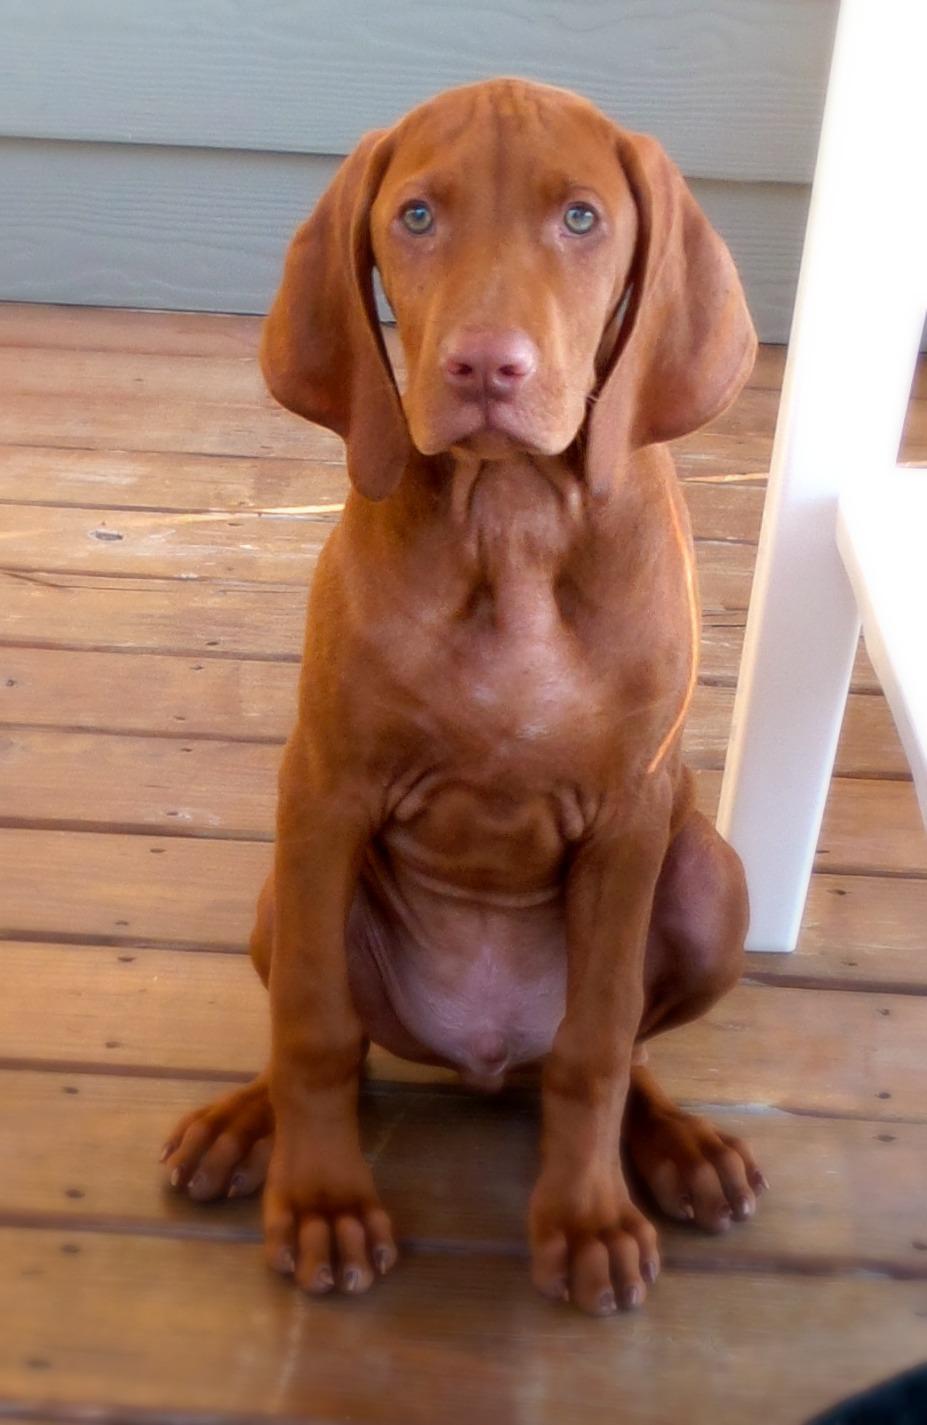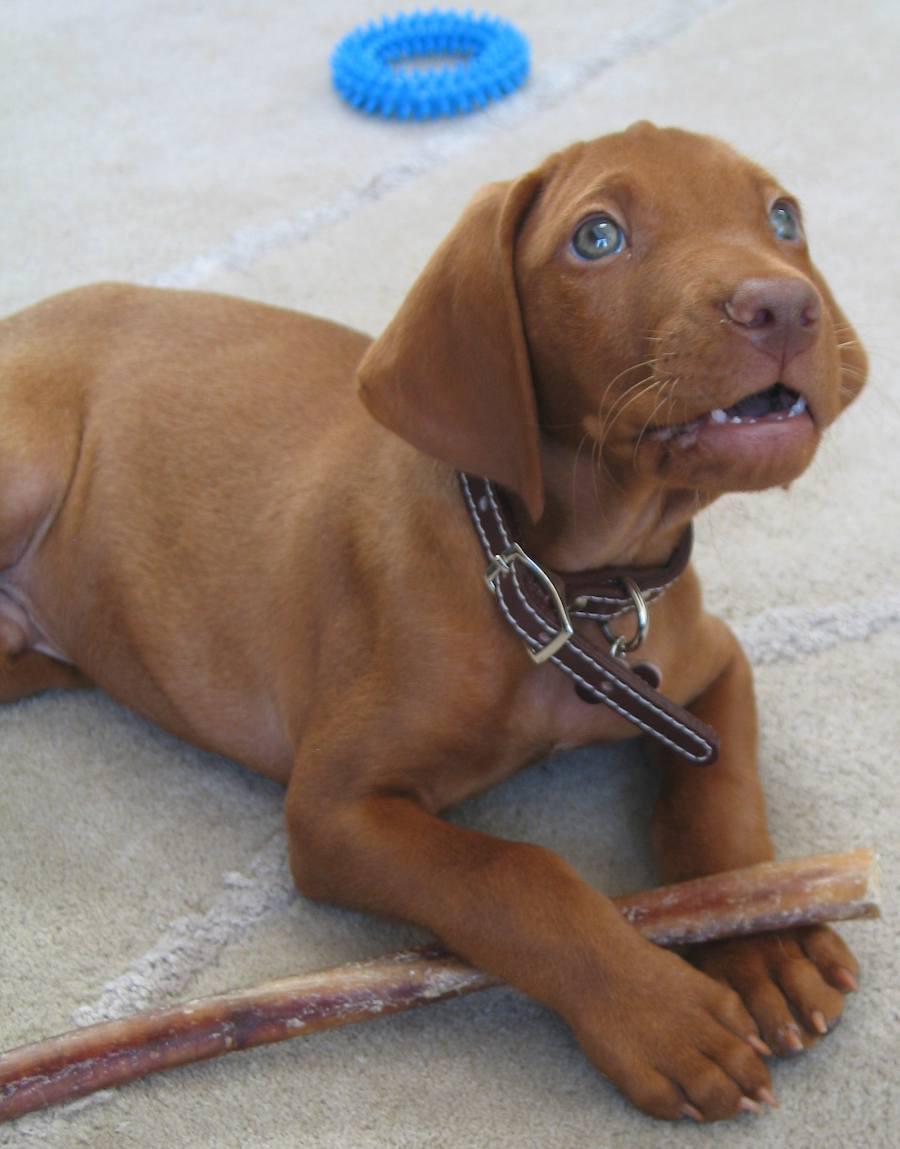The first image is the image on the left, the second image is the image on the right. Evaluate the accuracy of this statement regarding the images: "Each image contains only one dog, the left image features a dog turned forward and sitting upright, and the right image features a rightward-turned dog wearing a collar.". Is it true? Answer yes or no. Yes. The first image is the image on the left, the second image is the image on the right. For the images shown, is this caption "A single dog in the image on the left is sitting up." true? Answer yes or no. Yes. 